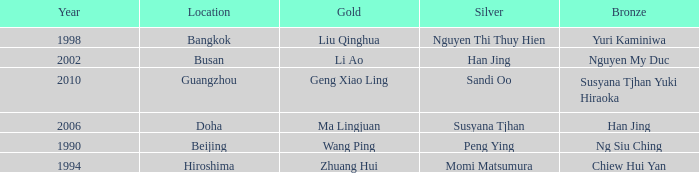What Silver has a Golf of Li AO? Han Jing. 